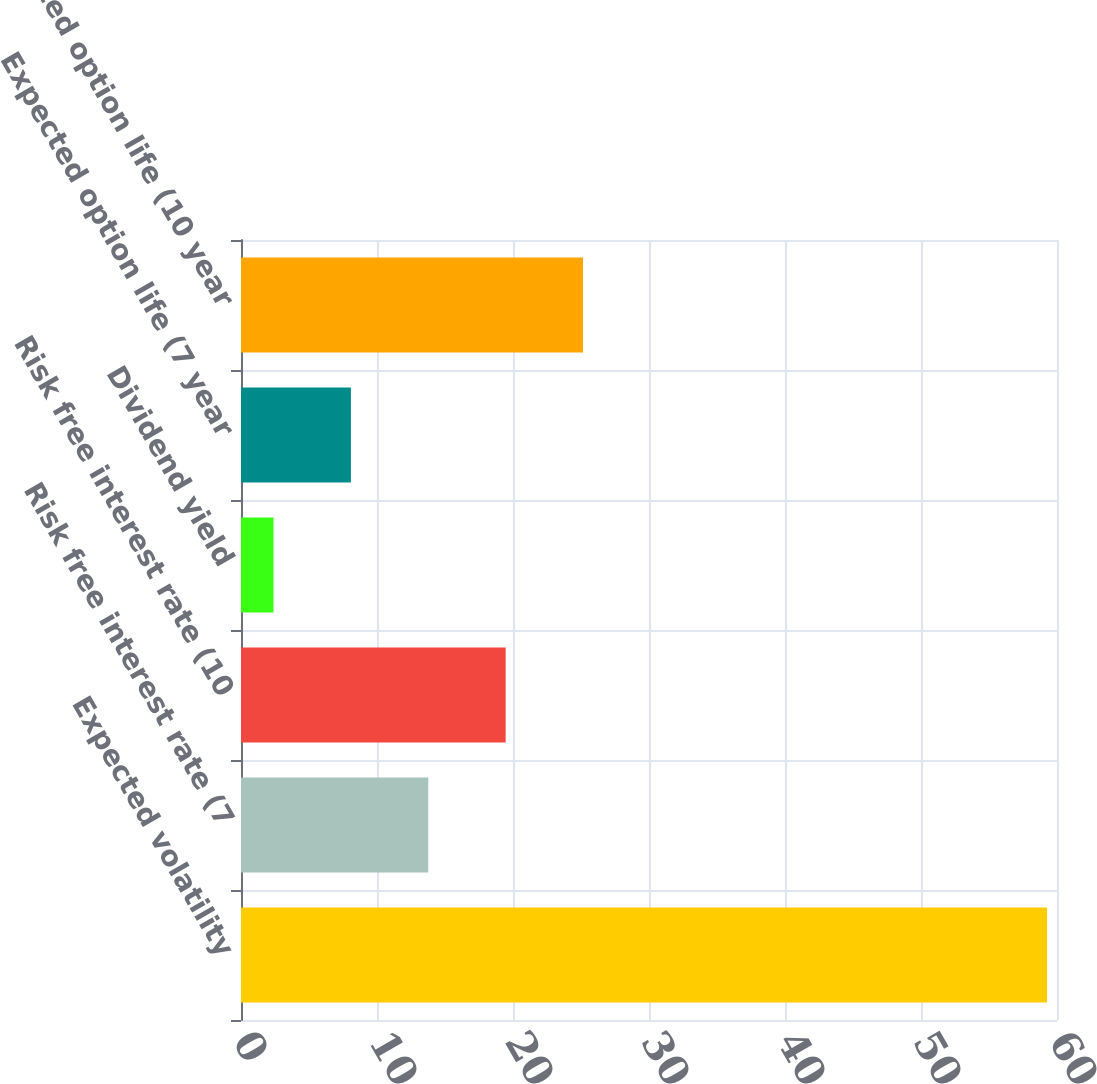<chart> <loc_0><loc_0><loc_500><loc_500><bar_chart><fcel>Expected volatility<fcel>Risk free interest rate (7<fcel>Risk free interest rate (10<fcel>Dividend yield<fcel>Expected option life (7 year<fcel>Expected option life (10 year<nl><fcel>59.27<fcel>13.77<fcel>19.46<fcel>2.39<fcel>8.08<fcel>25.15<nl></chart> 